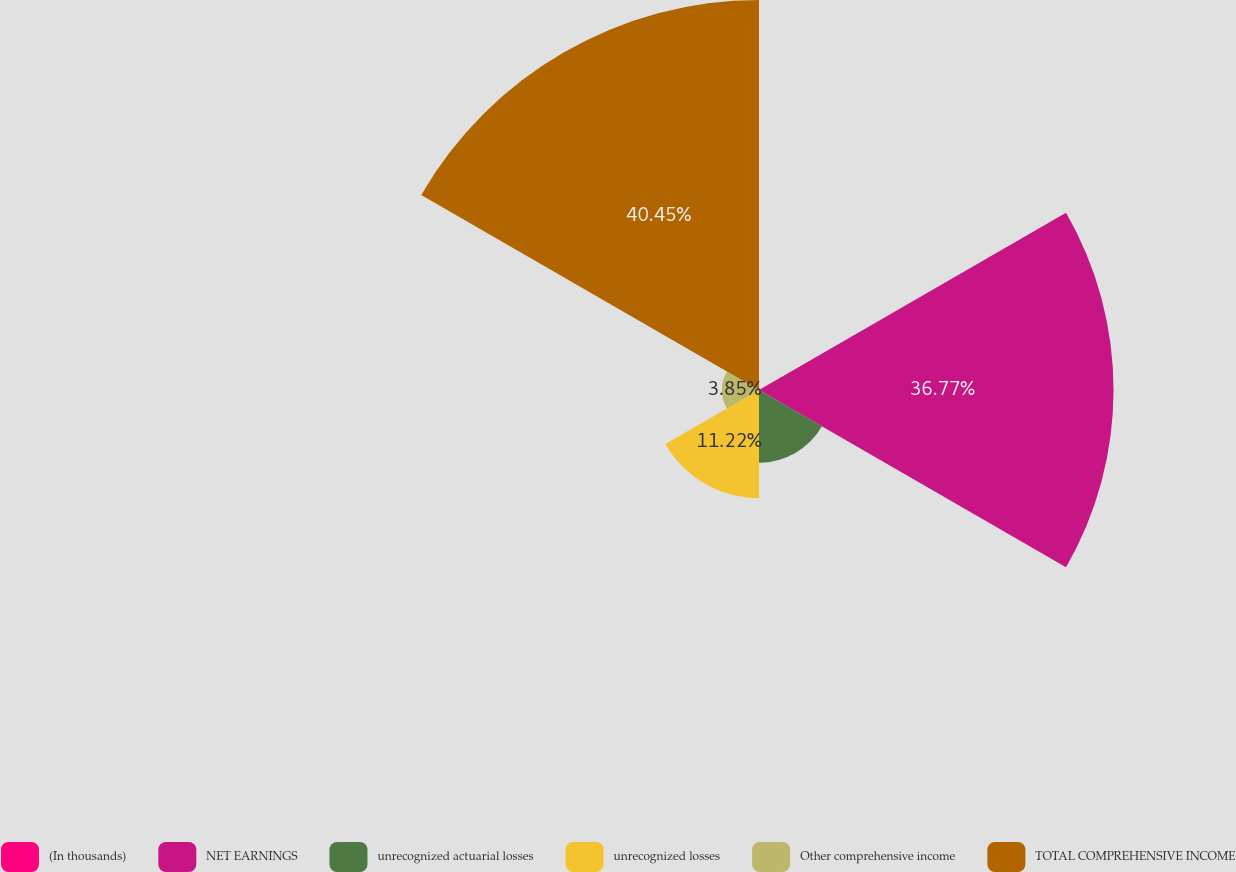<chart> <loc_0><loc_0><loc_500><loc_500><pie_chart><fcel>(In thousands)<fcel>NET EARNINGS<fcel>unrecognized actuarial losses<fcel>unrecognized losses<fcel>Other comprehensive income<fcel>TOTAL COMPREHENSIVE INCOME<nl><fcel>0.17%<fcel>36.77%<fcel>7.54%<fcel>11.22%<fcel>3.85%<fcel>40.45%<nl></chart> 